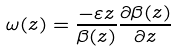Convert formula to latex. <formula><loc_0><loc_0><loc_500><loc_500>\omega ( z ) = \frac { - \varepsilon z } { \beta ( z ) } \frac { \partial \beta ( z ) } { \partial z }</formula> 